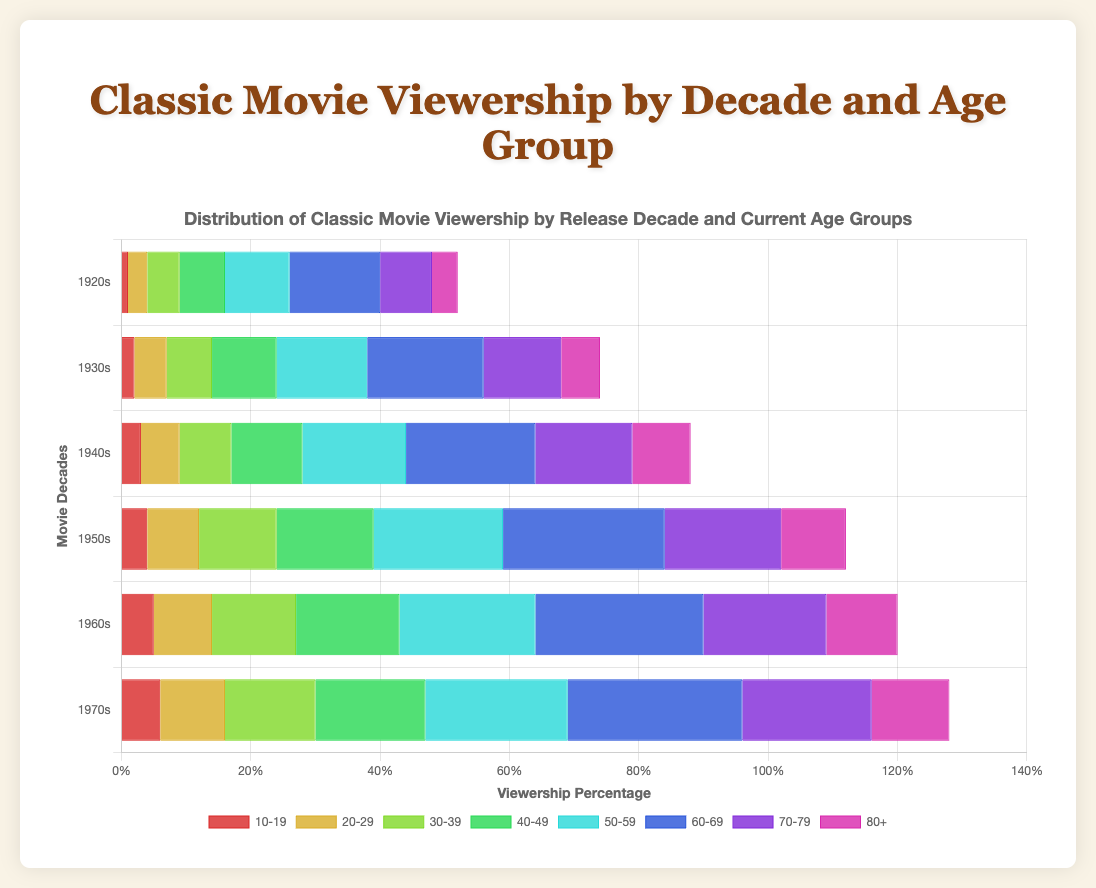Which age group has the highest viewership of movies from the 1950s? To find the highest viewership for 1950s movies, look for the tallest bar in the 1950s group. The age group 60-69 has the highest viewership, represented by the tallest bar.
Answer: 60-69 Which decade has the lowest viewership in the 10-19 age group? Compare the heights of the bars for the 10-19 age group across all decades. The shortest bar is in the 1920s group.
Answer: 1920s What's the total viewership percentage for 1940s movies among the age groups 30-39 and 40-49? Sum the heights of the bars for the 30-39 and 40-49 age groups in the 1940s decade. The values are 8% and 11%. Summing them gives 8 + 11 = 19.
Answer: 19% How does the viewership of 1930s movies compare between the 20-29 and 70-79 age groups? Compare the heights of the bars for the 20-29 and 70-79 age groups in the 1930s decade. The values are 5% and 12%. The 70-79 age group has higher viewership.
Answer: 70-79 Is the viewership for 1960s movies in the age group 50-59 higher or lower than that in the age group 60-69? Compare the heights of the bars for the 50-59 and 60-69 age groups in the 1960s decade. The values are 21% and 26%. The 60-69 age group has higher viewership.
Answer: Higher Which decade shows a consistent increase in viewership as age increases? Evaluate the trend in the heights of bars within each decade to see which decade's viewership consistently increases with age.  The 1970s decade shows such a trend.
Answer: 1970s What is the average viewership for 1970s movies across all age groups? Sum the viewership percentages for the 1970s decade across all age groups and divide by the number of age groups: (6 + 10 + 14 + 17 + 22 + 27 + 20 + 12) / 8. The sum is 128, so 128 / 8 = 16.
Answer: 16 By how much does the viewership for 1950s movies in the 60-69 age group exceed that in the 20-29 age group? Subtract the viewership percentage for the 20-29 age group from that for the 60-69 age group in the 1950s decade. The 60-69 viewership is 25% and the 20-29 viewership is 8%. So, 25 - 8 = 17.
Answer: 17 Do any age groups have an equal viewership of 1970s movies? Compare the viewership percentages of the 1970s across all age groups to see if any match. None of the percentages are equal across different age groups for the 1970s.
Answer: No 